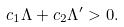Convert formula to latex. <formula><loc_0><loc_0><loc_500><loc_500>c _ { 1 } \Lambda + c _ { 2 } \Lambda ^ { \prime } > 0 .</formula> 